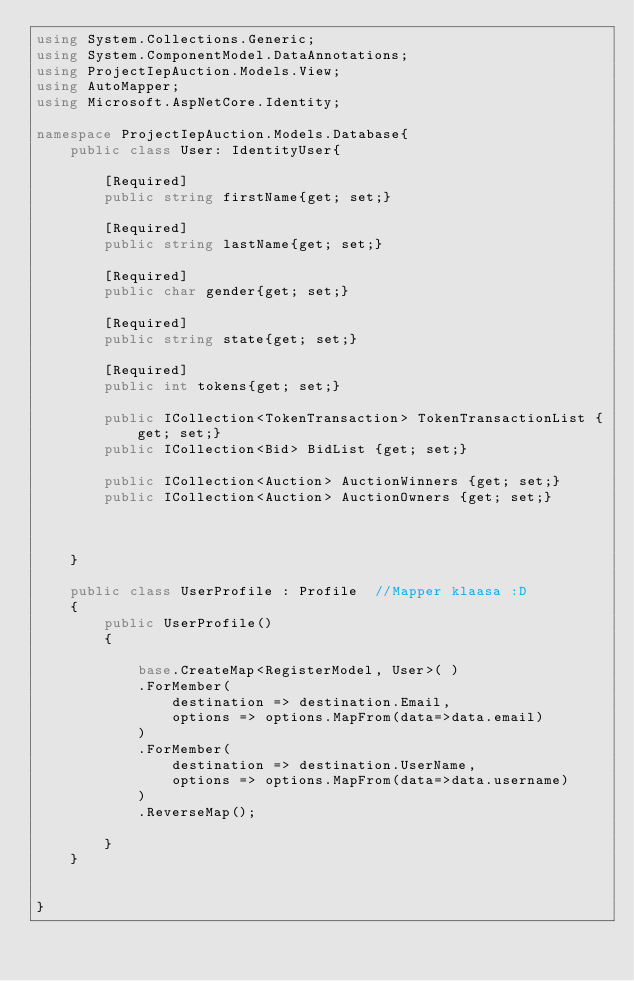<code> <loc_0><loc_0><loc_500><loc_500><_C#_>using System.Collections.Generic;
using System.ComponentModel.DataAnnotations;
using ProjectIepAuction.Models.View;
using AutoMapper;
using Microsoft.AspNetCore.Identity;

namespace ProjectIepAuction.Models.Database{
    public class User: IdentityUser{

        [Required]
        public string firstName{get; set;}

        [Required]
        public string lastName{get; set;}

        [Required]
        public char gender{get; set;}

        [Required]
        public string state{get; set;}

        [Required]
        public int tokens{get; set;}

        public ICollection<TokenTransaction> TokenTransactionList {get; set;}
        public ICollection<Bid> BidList {get; set;}

        public ICollection<Auction> AuctionWinners {get; set;}
        public ICollection<Auction> AuctionOwners {get; set;}

      
        
    }

    public class UserProfile : Profile  //Mapper klaasa :D
    {
        public UserProfile()
        {

            base.CreateMap<RegisterModel, User>( )
            .ForMember(
                destination => destination.Email,
                options => options.MapFrom(data=>data.email)
            ) 
            .ForMember(
                destination => destination.UserName,
                options => options.MapFrom(data=>data.username)
            )
            .ReverseMap();
        
        }
    }
    

}</code> 